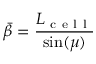Convert formula to latex. <formula><loc_0><loc_0><loc_500><loc_500>\ B a r { \beta } = \frac { L _ { c e l l } } { \sin ( \mu ) }</formula> 